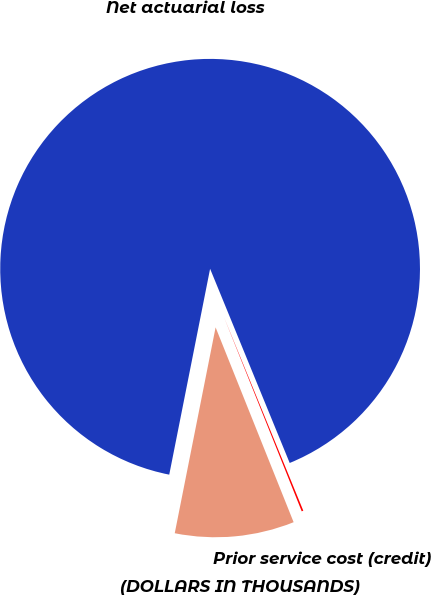Convert chart. <chart><loc_0><loc_0><loc_500><loc_500><pie_chart><fcel>(DOLLARS IN THOUSANDS)<fcel>Net actuarial loss<fcel>Prior service cost (credit)<nl><fcel>9.18%<fcel>90.69%<fcel>0.13%<nl></chart> 